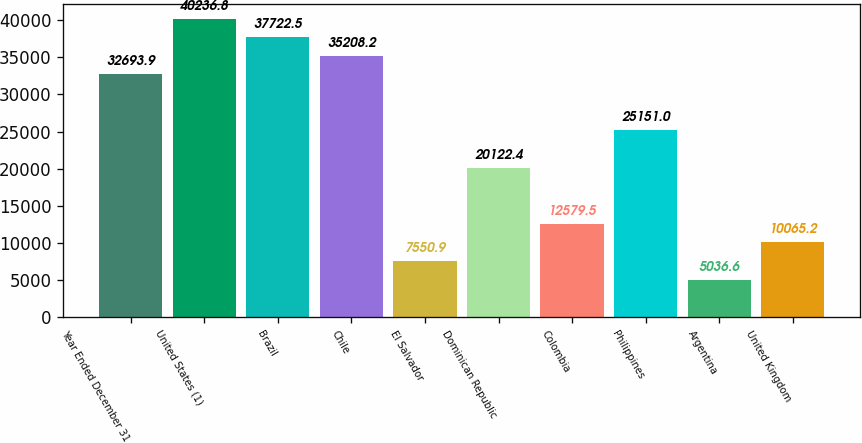Convert chart. <chart><loc_0><loc_0><loc_500><loc_500><bar_chart><fcel>Year Ended December 31<fcel>United States (1)<fcel>Brazil<fcel>Chile<fcel>El Salvador<fcel>Dominican Republic<fcel>Colombia<fcel>Philippines<fcel>Argentina<fcel>United Kingdom<nl><fcel>32693.9<fcel>40236.8<fcel>37722.5<fcel>35208.2<fcel>7550.9<fcel>20122.4<fcel>12579.5<fcel>25151<fcel>5036.6<fcel>10065.2<nl></chart> 